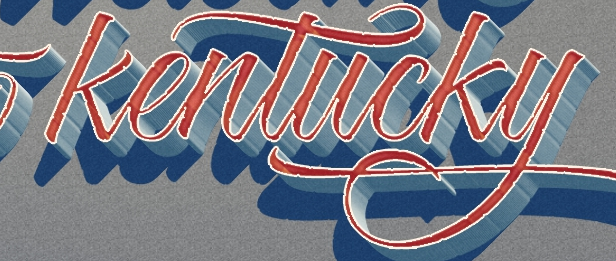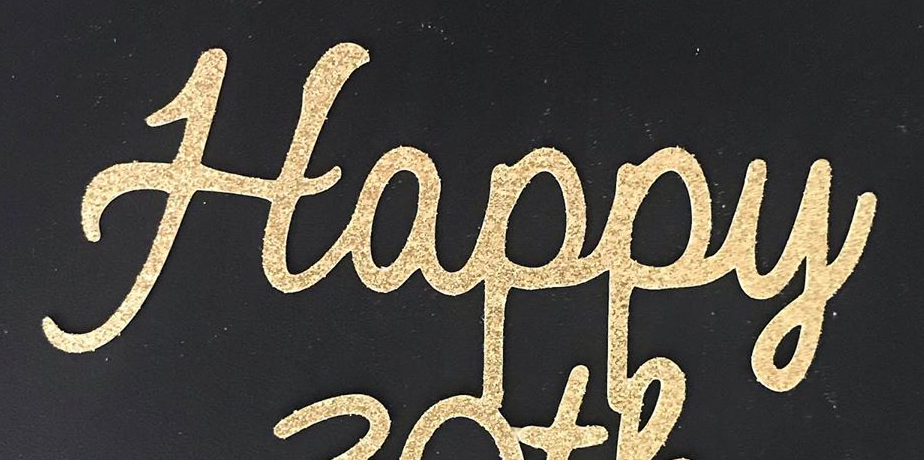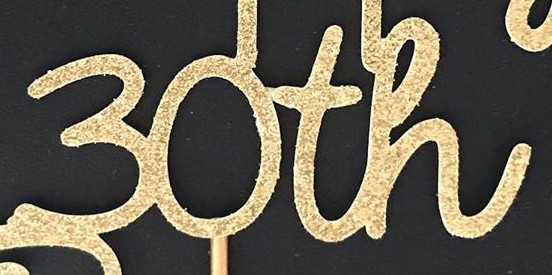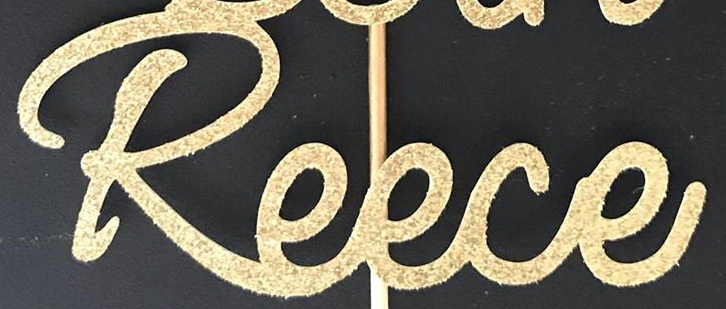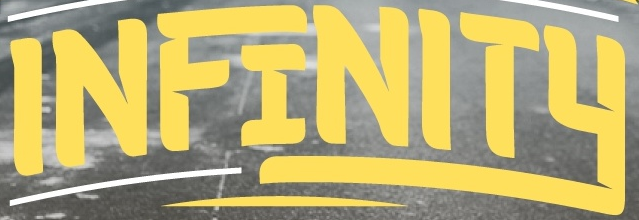Read the text from these images in sequence, separated by a semicolon. kentucky; Happy; 30th; Reece; INFINITY 